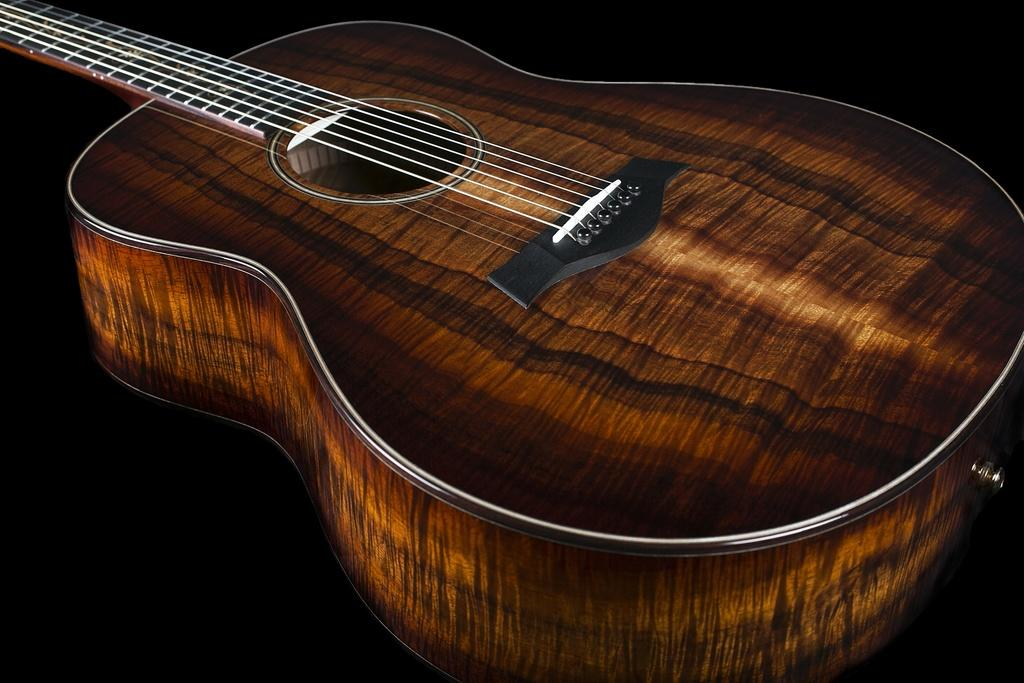What musical instrument is present in the picture? There is a guitar in the picture. What material is the guitar made of? The guitar is made of wood. What color are the strings of the guitar? The strings of the guitar are white in color. Can you see any snakes wrapped around the guitar in the image? No, there are no snakes present in the image. What type of trees can be seen near the guitar in the image? There are no trees visible in the image; it only features a guitar. 